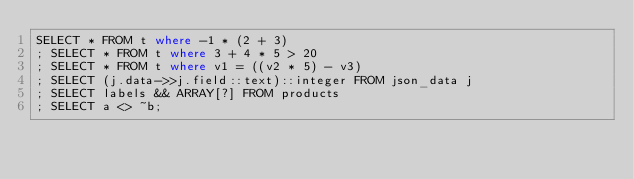Convert code to text. <code><loc_0><loc_0><loc_500><loc_500><_SQL_>SELECT * FROM t where -1 * (2 + 3)
; SELECT * FROM t where 3 + 4 * 5 > 20
; SELECT * FROM t where v1 = ((v2 * 5) - v3)
; SELECT (j.data->>j.field::text)::integer FROM json_data j
; SELECT labels && ARRAY[?] FROM products
; SELECT a <> ~b;</code> 